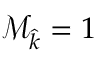<formula> <loc_0><loc_0><loc_500><loc_500>\mathcal { M } _ { \widehat { k } } = 1</formula> 